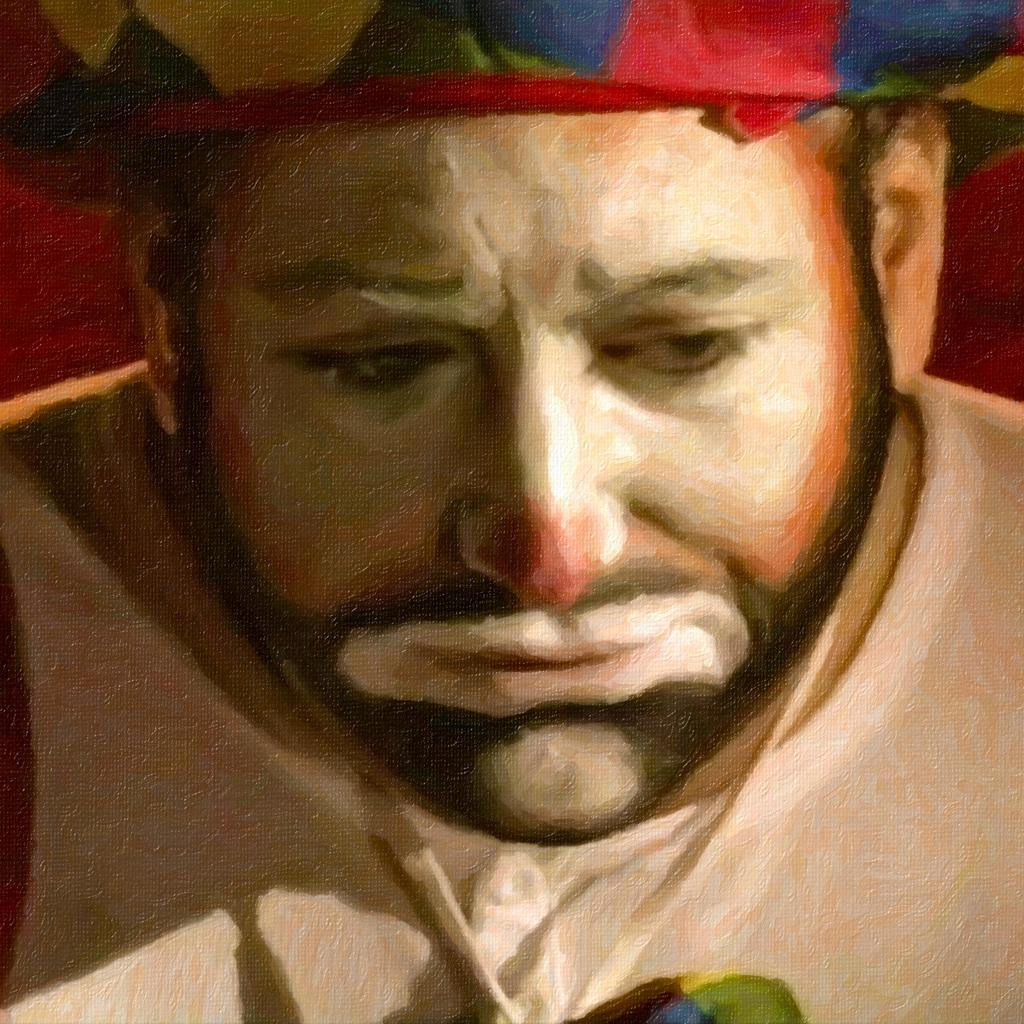What is depicted in the image? There is a painting of a person in the image. Can you describe the person's face in the painting? The face of the person in the painting has white color paint on it. What type of reward is the person holding in the painting? There is no reward visible in the painting; it only depicts a person with white paint on their face. 